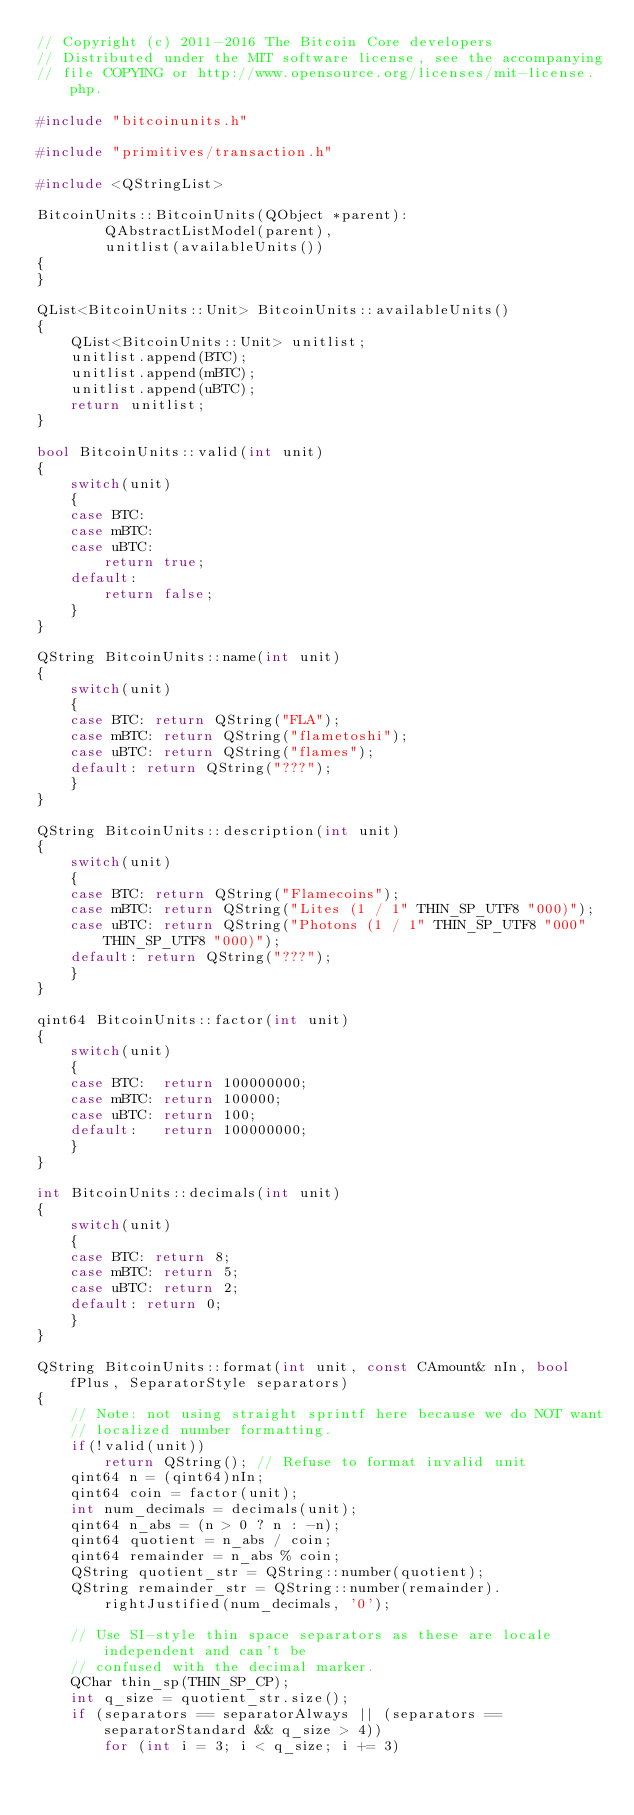<code> <loc_0><loc_0><loc_500><loc_500><_C++_>// Copyright (c) 2011-2016 The Bitcoin Core developers
// Distributed under the MIT software license, see the accompanying
// file COPYING or http://www.opensource.org/licenses/mit-license.php.

#include "bitcoinunits.h"

#include "primitives/transaction.h"

#include <QStringList>

BitcoinUnits::BitcoinUnits(QObject *parent):
        QAbstractListModel(parent),
        unitlist(availableUnits())
{
}

QList<BitcoinUnits::Unit> BitcoinUnits::availableUnits()
{
    QList<BitcoinUnits::Unit> unitlist;
    unitlist.append(BTC);
    unitlist.append(mBTC);
    unitlist.append(uBTC);
    return unitlist;
}

bool BitcoinUnits::valid(int unit)
{
    switch(unit)
    {
    case BTC:
    case mBTC:
    case uBTC:
        return true;
    default:
        return false;
    }
}

QString BitcoinUnits::name(int unit)
{
    switch(unit)
    {
    case BTC: return QString("FLA");
    case mBTC: return QString("flametoshi");
    case uBTC: return QString("flames");
    default: return QString("???");
    }
}

QString BitcoinUnits::description(int unit)
{
    switch(unit)
    {
    case BTC: return QString("Flamecoins");
    case mBTC: return QString("Lites (1 / 1" THIN_SP_UTF8 "000)");
    case uBTC: return QString("Photons (1 / 1" THIN_SP_UTF8 "000" THIN_SP_UTF8 "000)");
    default: return QString("???");
    }
}

qint64 BitcoinUnits::factor(int unit)
{
    switch(unit)
    {
    case BTC:  return 100000000;
    case mBTC: return 100000;
    case uBTC: return 100;
    default:   return 100000000;
    }
}

int BitcoinUnits::decimals(int unit)
{
    switch(unit)
    {
    case BTC: return 8;
    case mBTC: return 5;
    case uBTC: return 2;
    default: return 0;
    }
}

QString BitcoinUnits::format(int unit, const CAmount& nIn, bool fPlus, SeparatorStyle separators)
{
    // Note: not using straight sprintf here because we do NOT want
    // localized number formatting.
    if(!valid(unit))
        return QString(); // Refuse to format invalid unit
    qint64 n = (qint64)nIn;
    qint64 coin = factor(unit);
    int num_decimals = decimals(unit);
    qint64 n_abs = (n > 0 ? n : -n);
    qint64 quotient = n_abs / coin;
    qint64 remainder = n_abs % coin;
    QString quotient_str = QString::number(quotient);
    QString remainder_str = QString::number(remainder).rightJustified(num_decimals, '0');

    // Use SI-style thin space separators as these are locale independent and can't be
    // confused with the decimal marker.
    QChar thin_sp(THIN_SP_CP);
    int q_size = quotient_str.size();
    if (separators == separatorAlways || (separators == separatorStandard && q_size > 4))
        for (int i = 3; i < q_size; i += 3)</code> 